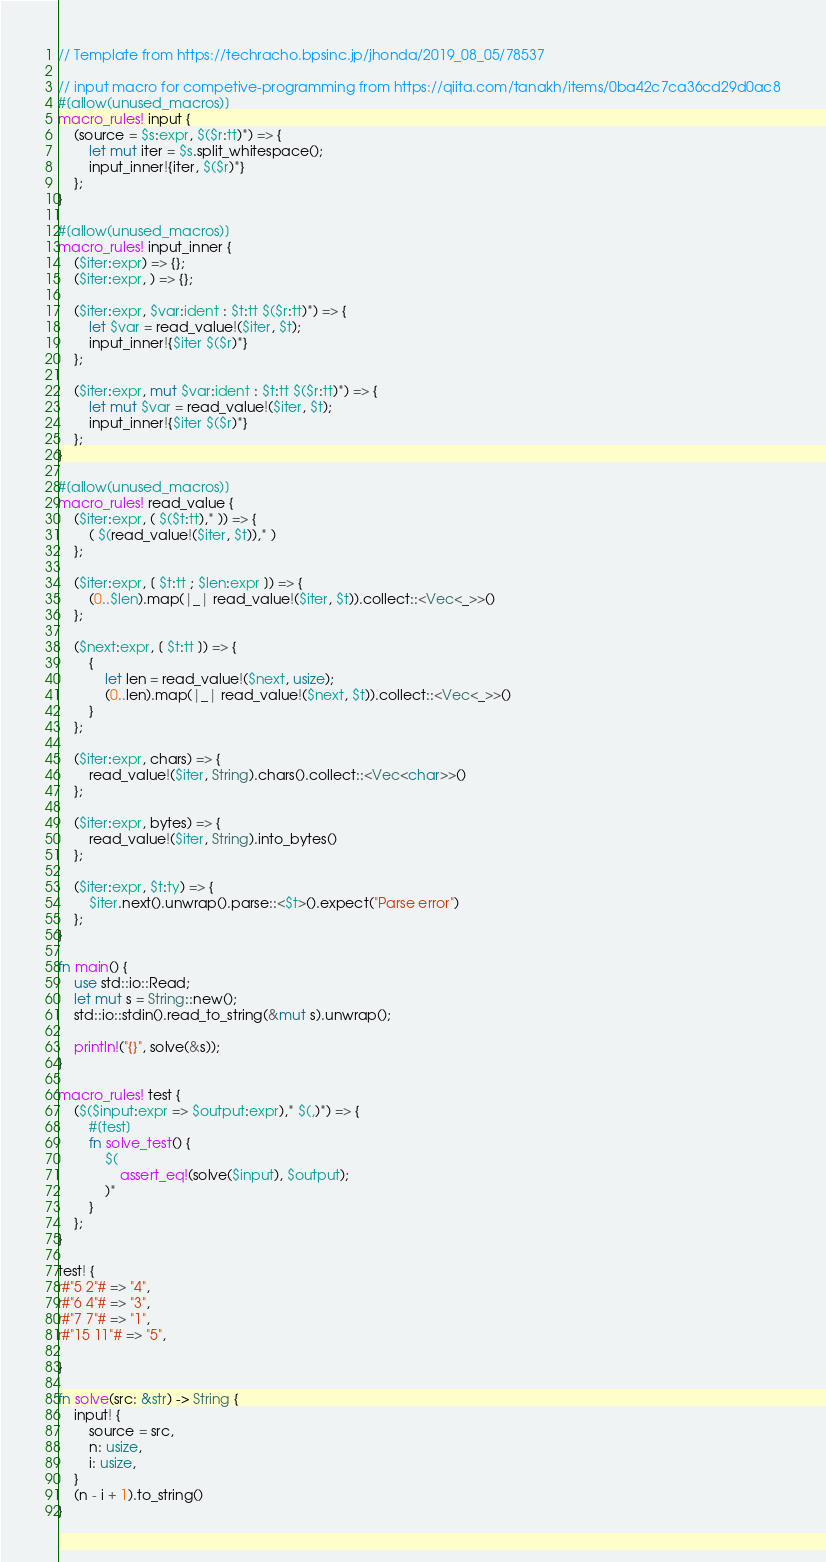<code> <loc_0><loc_0><loc_500><loc_500><_Rust_>// Template from https://techracho.bpsinc.jp/jhonda/2019_08_05/78537

// input macro for competive-programming from https://qiita.com/tanakh/items/0ba42c7ca36cd29d0ac8
#[allow(unused_macros)]
macro_rules! input {
    (source = $s:expr, $($r:tt)*) => {
        let mut iter = $s.split_whitespace();
        input_inner!{iter, $($r)*}
    };
}

#[allow(unused_macros)]
macro_rules! input_inner {
    ($iter:expr) => {};
    ($iter:expr, ) => {};

    ($iter:expr, $var:ident : $t:tt $($r:tt)*) => {
        let $var = read_value!($iter, $t);
        input_inner!{$iter $($r)*}
    };

    ($iter:expr, mut $var:ident : $t:tt $($r:tt)*) => {
        let mut $var = read_value!($iter, $t);
        input_inner!{$iter $($r)*}
    };
}

#[allow(unused_macros)]
macro_rules! read_value {
    ($iter:expr, ( $($t:tt),* )) => {
        ( $(read_value!($iter, $t)),* )
    };

    ($iter:expr, [ $t:tt ; $len:expr ]) => {
        (0..$len).map(|_| read_value!($iter, $t)).collect::<Vec<_>>()
    };

    ($next:expr, [ $t:tt ]) => {
        {
            let len = read_value!($next, usize);
            (0..len).map(|_| read_value!($next, $t)).collect::<Vec<_>>()
        }
    };

    ($iter:expr, chars) => {
        read_value!($iter, String).chars().collect::<Vec<char>>()
    };

    ($iter:expr, bytes) => {
        read_value!($iter, String).into_bytes()
    };

    ($iter:expr, $t:ty) => {
        $iter.next().unwrap().parse::<$t>().expect("Parse error")
    };
}

fn main() {
    use std::io::Read;
    let mut s = String::new();
    std::io::stdin().read_to_string(&mut s).unwrap();

    println!("{}", solve(&s));
}

macro_rules! test {
    ($($input:expr => $output:expr),* $(,)*) => {
        #[test]
        fn solve_test() {
            $(
                assert_eq!(solve($input), $output);
            )*
        }
    };
}

test! {
r#"5 2"# => "4",
r#"6 4"# => "3",
r#"7 7"# => "1",
r#"15 11"# => "5",

}

fn solve(src: &str) -> String {
    input! {
        source = src,
        n: usize,
        i: usize,
    }
    (n - i + 1).to_string()
}</code> 